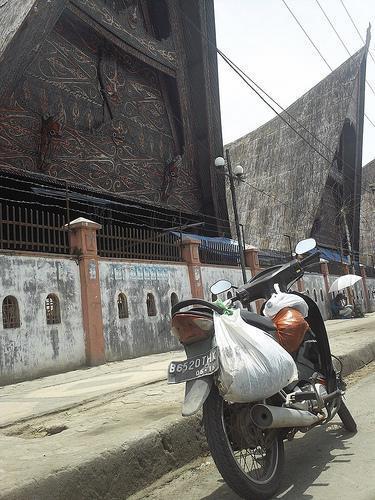How many people are getting in motor?
Give a very brief answer. 0. 